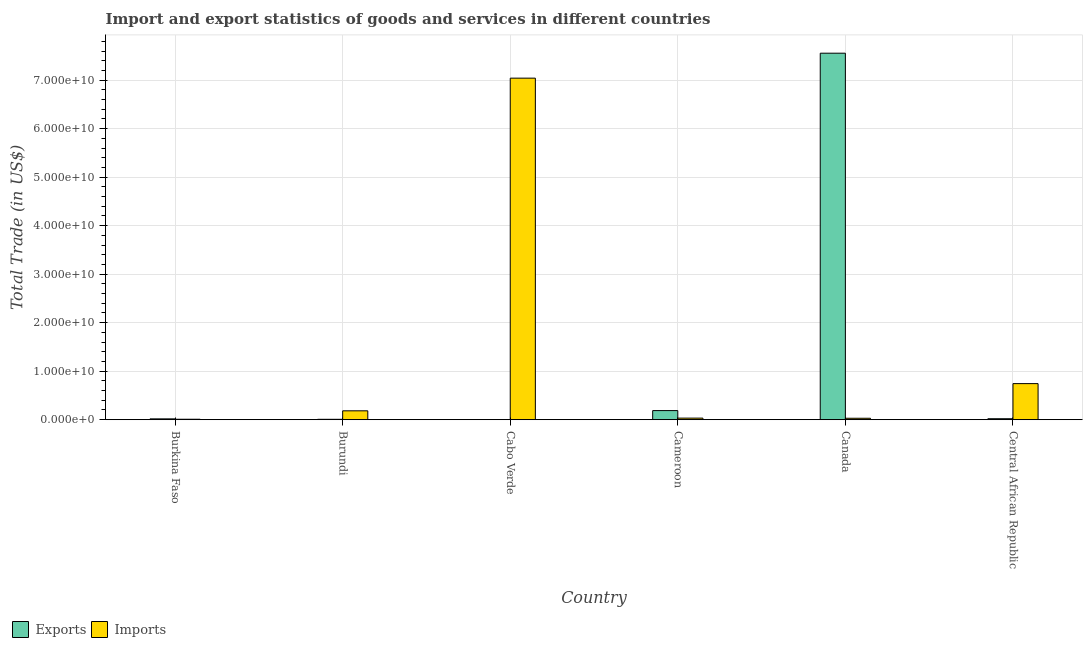How many different coloured bars are there?
Your answer should be very brief. 2. How many groups of bars are there?
Ensure brevity in your answer.  6. What is the label of the 2nd group of bars from the left?
Your answer should be very brief. Burundi. What is the imports of goods and services in Cameroon?
Your answer should be compact. 3.27e+08. Across all countries, what is the maximum export of goods and services?
Give a very brief answer. 7.55e+1. Across all countries, what is the minimum imports of goods and services?
Your response must be concise. 9.53e+07. In which country was the imports of goods and services maximum?
Make the answer very short. Cabo Verde. In which country was the export of goods and services minimum?
Provide a succinct answer. Cabo Verde. What is the total imports of goods and services in the graph?
Provide a succinct answer. 8.04e+1. What is the difference between the export of goods and services in Burkina Faso and that in Canada?
Give a very brief answer. -7.54e+1. What is the difference between the imports of goods and services in Burkina Faso and the export of goods and services in Burundi?
Your answer should be compact. 1.42e+07. What is the average export of goods and services per country?
Provide a short and direct response. 1.30e+1. What is the difference between the export of goods and services and imports of goods and services in Canada?
Provide a short and direct response. 7.53e+1. What is the ratio of the imports of goods and services in Cabo Verde to that in Central African Republic?
Offer a terse response. 9.46. Is the difference between the export of goods and services in Burkina Faso and Canada greater than the difference between the imports of goods and services in Burkina Faso and Canada?
Ensure brevity in your answer.  No. What is the difference between the highest and the second highest imports of goods and services?
Provide a succinct answer. 6.30e+1. What is the difference between the highest and the lowest export of goods and services?
Your answer should be compact. 7.55e+1. In how many countries, is the export of goods and services greater than the average export of goods and services taken over all countries?
Provide a succinct answer. 1. What does the 1st bar from the left in Burkina Faso represents?
Your answer should be very brief. Exports. What does the 1st bar from the right in Canada represents?
Provide a succinct answer. Imports. Are the values on the major ticks of Y-axis written in scientific E-notation?
Offer a terse response. Yes. Does the graph contain grids?
Keep it short and to the point. Yes. How many legend labels are there?
Ensure brevity in your answer.  2. What is the title of the graph?
Your response must be concise. Import and export statistics of goods and services in different countries. Does "Young" appear as one of the legend labels in the graph?
Ensure brevity in your answer.  No. What is the label or title of the Y-axis?
Make the answer very short. Total Trade (in US$). What is the Total Trade (in US$) in Exports in Burkina Faso?
Provide a succinct answer. 1.73e+08. What is the Total Trade (in US$) in Imports in Burkina Faso?
Ensure brevity in your answer.  9.53e+07. What is the Total Trade (in US$) of Exports in Burundi?
Offer a very short reply. 8.10e+07. What is the Total Trade (in US$) of Imports in Burundi?
Offer a terse response. 1.83e+09. What is the Total Trade (in US$) of Exports in Cabo Verde?
Keep it short and to the point. 2.43e+07. What is the Total Trade (in US$) of Imports in Cabo Verde?
Your answer should be compact. 7.04e+1. What is the Total Trade (in US$) in Exports in Cameroon?
Provide a short and direct response. 1.88e+09. What is the Total Trade (in US$) of Imports in Cameroon?
Your answer should be very brief. 3.27e+08. What is the Total Trade (in US$) of Exports in Canada?
Your answer should be compact. 7.55e+1. What is the Total Trade (in US$) in Imports in Canada?
Give a very brief answer. 2.98e+08. What is the Total Trade (in US$) in Exports in Central African Republic?
Keep it short and to the point. 2.01e+08. What is the Total Trade (in US$) in Imports in Central African Republic?
Make the answer very short. 7.44e+09. Across all countries, what is the maximum Total Trade (in US$) in Exports?
Keep it short and to the point. 7.55e+1. Across all countries, what is the maximum Total Trade (in US$) in Imports?
Provide a succinct answer. 7.04e+1. Across all countries, what is the minimum Total Trade (in US$) of Exports?
Keep it short and to the point. 2.43e+07. Across all countries, what is the minimum Total Trade (in US$) in Imports?
Provide a succinct answer. 9.53e+07. What is the total Total Trade (in US$) in Exports in the graph?
Make the answer very short. 7.79e+1. What is the total Total Trade (in US$) in Imports in the graph?
Provide a succinct answer. 8.04e+1. What is the difference between the Total Trade (in US$) of Exports in Burkina Faso and that in Burundi?
Your response must be concise. 9.16e+07. What is the difference between the Total Trade (in US$) in Imports in Burkina Faso and that in Burundi?
Provide a short and direct response. -1.73e+09. What is the difference between the Total Trade (in US$) of Exports in Burkina Faso and that in Cabo Verde?
Keep it short and to the point. 1.48e+08. What is the difference between the Total Trade (in US$) in Imports in Burkina Faso and that in Cabo Verde?
Your response must be concise. -7.03e+1. What is the difference between the Total Trade (in US$) of Exports in Burkina Faso and that in Cameroon?
Your response must be concise. -1.71e+09. What is the difference between the Total Trade (in US$) in Imports in Burkina Faso and that in Cameroon?
Make the answer very short. -2.32e+08. What is the difference between the Total Trade (in US$) of Exports in Burkina Faso and that in Canada?
Offer a terse response. -7.54e+1. What is the difference between the Total Trade (in US$) of Imports in Burkina Faso and that in Canada?
Provide a short and direct response. -2.03e+08. What is the difference between the Total Trade (in US$) in Exports in Burkina Faso and that in Central African Republic?
Your answer should be compact. -2.84e+07. What is the difference between the Total Trade (in US$) of Imports in Burkina Faso and that in Central African Republic?
Your answer should be very brief. -7.34e+09. What is the difference between the Total Trade (in US$) in Exports in Burundi and that in Cabo Verde?
Keep it short and to the point. 5.67e+07. What is the difference between the Total Trade (in US$) in Imports in Burundi and that in Cabo Verde?
Make the answer very short. -6.86e+1. What is the difference between the Total Trade (in US$) of Exports in Burundi and that in Cameroon?
Your answer should be compact. -1.80e+09. What is the difference between the Total Trade (in US$) in Imports in Burundi and that in Cameroon?
Keep it short and to the point. 1.50e+09. What is the difference between the Total Trade (in US$) in Exports in Burundi and that in Canada?
Provide a succinct answer. -7.55e+1. What is the difference between the Total Trade (in US$) of Imports in Burundi and that in Canada?
Provide a short and direct response. 1.53e+09. What is the difference between the Total Trade (in US$) in Exports in Burundi and that in Central African Republic?
Make the answer very short. -1.20e+08. What is the difference between the Total Trade (in US$) of Imports in Burundi and that in Central African Republic?
Offer a very short reply. -5.61e+09. What is the difference between the Total Trade (in US$) in Exports in Cabo Verde and that in Cameroon?
Offer a very short reply. -1.86e+09. What is the difference between the Total Trade (in US$) of Imports in Cabo Verde and that in Cameroon?
Provide a succinct answer. 7.01e+1. What is the difference between the Total Trade (in US$) of Exports in Cabo Verde and that in Canada?
Ensure brevity in your answer.  -7.55e+1. What is the difference between the Total Trade (in US$) of Imports in Cabo Verde and that in Canada?
Keep it short and to the point. 7.01e+1. What is the difference between the Total Trade (in US$) of Exports in Cabo Verde and that in Central African Republic?
Offer a very short reply. -1.77e+08. What is the difference between the Total Trade (in US$) in Imports in Cabo Verde and that in Central African Republic?
Offer a terse response. 6.30e+1. What is the difference between the Total Trade (in US$) in Exports in Cameroon and that in Canada?
Offer a terse response. -7.37e+1. What is the difference between the Total Trade (in US$) in Imports in Cameroon and that in Canada?
Give a very brief answer. 2.93e+07. What is the difference between the Total Trade (in US$) in Exports in Cameroon and that in Central African Republic?
Your response must be concise. 1.68e+09. What is the difference between the Total Trade (in US$) of Imports in Cameroon and that in Central African Republic?
Provide a succinct answer. -7.11e+09. What is the difference between the Total Trade (in US$) of Exports in Canada and that in Central African Republic?
Give a very brief answer. 7.53e+1. What is the difference between the Total Trade (in US$) in Imports in Canada and that in Central African Republic?
Ensure brevity in your answer.  -7.14e+09. What is the difference between the Total Trade (in US$) in Exports in Burkina Faso and the Total Trade (in US$) in Imports in Burundi?
Make the answer very short. -1.66e+09. What is the difference between the Total Trade (in US$) of Exports in Burkina Faso and the Total Trade (in US$) of Imports in Cabo Verde?
Give a very brief answer. -7.02e+1. What is the difference between the Total Trade (in US$) in Exports in Burkina Faso and the Total Trade (in US$) in Imports in Cameroon?
Offer a terse response. -1.55e+08. What is the difference between the Total Trade (in US$) in Exports in Burkina Faso and the Total Trade (in US$) in Imports in Canada?
Provide a short and direct response. -1.26e+08. What is the difference between the Total Trade (in US$) in Exports in Burkina Faso and the Total Trade (in US$) in Imports in Central African Republic?
Your answer should be compact. -7.27e+09. What is the difference between the Total Trade (in US$) of Exports in Burundi and the Total Trade (in US$) of Imports in Cabo Verde?
Keep it short and to the point. -7.03e+1. What is the difference between the Total Trade (in US$) of Exports in Burundi and the Total Trade (in US$) of Imports in Cameroon?
Ensure brevity in your answer.  -2.46e+08. What is the difference between the Total Trade (in US$) in Exports in Burundi and the Total Trade (in US$) in Imports in Canada?
Provide a succinct answer. -2.17e+08. What is the difference between the Total Trade (in US$) in Exports in Burundi and the Total Trade (in US$) in Imports in Central African Republic?
Give a very brief answer. -7.36e+09. What is the difference between the Total Trade (in US$) of Exports in Cabo Verde and the Total Trade (in US$) of Imports in Cameroon?
Provide a succinct answer. -3.03e+08. What is the difference between the Total Trade (in US$) in Exports in Cabo Verde and the Total Trade (in US$) in Imports in Canada?
Keep it short and to the point. -2.74e+08. What is the difference between the Total Trade (in US$) in Exports in Cabo Verde and the Total Trade (in US$) in Imports in Central African Republic?
Give a very brief answer. -7.41e+09. What is the difference between the Total Trade (in US$) of Exports in Cameroon and the Total Trade (in US$) of Imports in Canada?
Ensure brevity in your answer.  1.58e+09. What is the difference between the Total Trade (in US$) of Exports in Cameroon and the Total Trade (in US$) of Imports in Central African Republic?
Your response must be concise. -5.56e+09. What is the difference between the Total Trade (in US$) of Exports in Canada and the Total Trade (in US$) of Imports in Central African Republic?
Give a very brief answer. 6.81e+1. What is the average Total Trade (in US$) in Exports per country?
Provide a succinct answer. 1.30e+1. What is the average Total Trade (in US$) in Imports per country?
Give a very brief answer. 1.34e+1. What is the difference between the Total Trade (in US$) in Exports and Total Trade (in US$) in Imports in Burkina Faso?
Ensure brevity in your answer.  7.74e+07. What is the difference between the Total Trade (in US$) of Exports and Total Trade (in US$) of Imports in Burundi?
Ensure brevity in your answer.  -1.75e+09. What is the difference between the Total Trade (in US$) of Exports and Total Trade (in US$) of Imports in Cabo Verde?
Offer a terse response. -7.04e+1. What is the difference between the Total Trade (in US$) in Exports and Total Trade (in US$) in Imports in Cameroon?
Offer a very short reply. 1.55e+09. What is the difference between the Total Trade (in US$) of Exports and Total Trade (in US$) of Imports in Canada?
Offer a very short reply. 7.53e+1. What is the difference between the Total Trade (in US$) of Exports and Total Trade (in US$) of Imports in Central African Republic?
Your answer should be compact. -7.24e+09. What is the ratio of the Total Trade (in US$) in Exports in Burkina Faso to that in Burundi?
Provide a succinct answer. 2.13. What is the ratio of the Total Trade (in US$) in Imports in Burkina Faso to that in Burundi?
Keep it short and to the point. 0.05. What is the ratio of the Total Trade (in US$) of Exports in Burkina Faso to that in Cabo Verde?
Ensure brevity in your answer.  7.11. What is the ratio of the Total Trade (in US$) in Imports in Burkina Faso to that in Cabo Verde?
Offer a terse response. 0. What is the ratio of the Total Trade (in US$) of Exports in Burkina Faso to that in Cameroon?
Your answer should be compact. 0.09. What is the ratio of the Total Trade (in US$) of Imports in Burkina Faso to that in Cameroon?
Provide a short and direct response. 0.29. What is the ratio of the Total Trade (in US$) in Exports in Burkina Faso to that in Canada?
Offer a very short reply. 0. What is the ratio of the Total Trade (in US$) of Imports in Burkina Faso to that in Canada?
Provide a succinct answer. 0.32. What is the ratio of the Total Trade (in US$) in Exports in Burkina Faso to that in Central African Republic?
Offer a terse response. 0.86. What is the ratio of the Total Trade (in US$) in Imports in Burkina Faso to that in Central African Republic?
Give a very brief answer. 0.01. What is the ratio of the Total Trade (in US$) in Exports in Burundi to that in Cabo Verde?
Offer a terse response. 3.34. What is the ratio of the Total Trade (in US$) of Imports in Burundi to that in Cabo Verde?
Offer a terse response. 0.03. What is the ratio of the Total Trade (in US$) in Exports in Burundi to that in Cameroon?
Keep it short and to the point. 0.04. What is the ratio of the Total Trade (in US$) of Imports in Burundi to that in Cameroon?
Ensure brevity in your answer.  5.59. What is the ratio of the Total Trade (in US$) in Exports in Burundi to that in Canada?
Your answer should be compact. 0. What is the ratio of the Total Trade (in US$) of Imports in Burundi to that in Canada?
Keep it short and to the point. 6.13. What is the ratio of the Total Trade (in US$) in Exports in Burundi to that in Central African Republic?
Your answer should be compact. 0.4. What is the ratio of the Total Trade (in US$) in Imports in Burundi to that in Central African Republic?
Your answer should be compact. 0.25. What is the ratio of the Total Trade (in US$) of Exports in Cabo Verde to that in Cameroon?
Provide a short and direct response. 0.01. What is the ratio of the Total Trade (in US$) in Imports in Cabo Verde to that in Cameroon?
Make the answer very short. 215.02. What is the ratio of the Total Trade (in US$) in Imports in Cabo Verde to that in Canada?
Your answer should be very brief. 236.11. What is the ratio of the Total Trade (in US$) in Exports in Cabo Verde to that in Central African Republic?
Offer a very short reply. 0.12. What is the ratio of the Total Trade (in US$) in Imports in Cabo Verde to that in Central African Republic?
Offer a very short reply. 9.46. What is the ratio of the Total Trade (in US$) of Exports in Cameroon to that in Canada?
Offer a very short reply. 0.02. What is the ratio of the Total Trade (in US$) in Imports in Cameroon to that in Canada?
Your answer should be compact. 1.1. What is the ratio of the Total Trade (in US$) of Exports in Cameroon to that in Central African Republic?
Your answer should be very brief. 9.35. What is the ratio of the Total Trade (in US$) of Imports in Cameroon to that in Central African Republic?
Your answer should be compact. 0.04. What is the ratio of the Total Trade (in US$) of Exports in Canada to that in Central African Republic?
Provide a succinct answer. 375.81. What is the ratio of the Total Trade (in US$) in Imports in Canada to that in Central African Republic?
Provide a short and direct response. 0.04. What is the difference between the highest and the second highest Total Trade (in US$) in Exports?
Offer a terse response. 7.37e+1. What is the difference between the highest and the second highest Total Trade (in US$) in Imports?
Make the answer very short. 6.30e+1. What is the difference between the highest and the lowest Total Trade (in US$) in Exports?
Your answer should be compact. 7.55e+1. What is the difference between the highest and the lowest Total Trade (in US$) in Imports?
Your answer should be compact. 7.03e+1. 